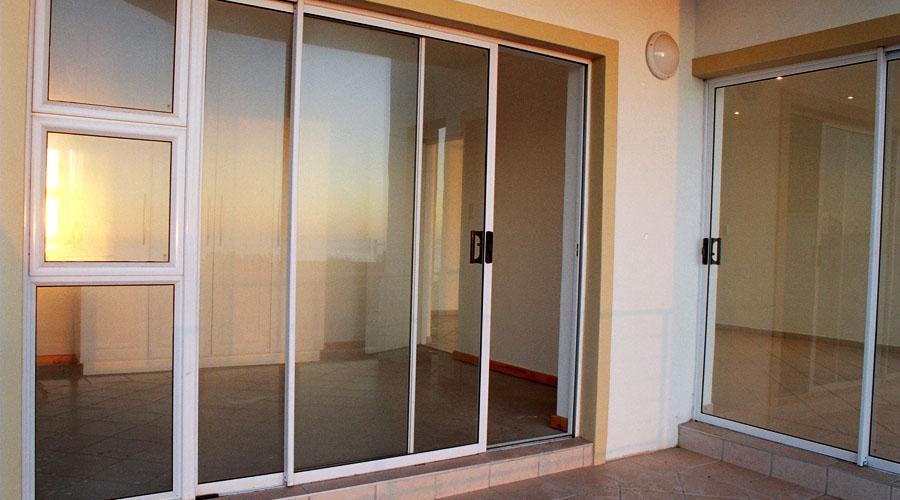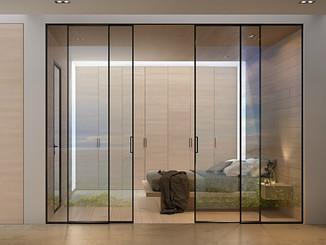The first image is the image on the left, the second image is the image on the right. For the images shown, is this caption "One door is solid wood." true? Answer yes or no. No. 